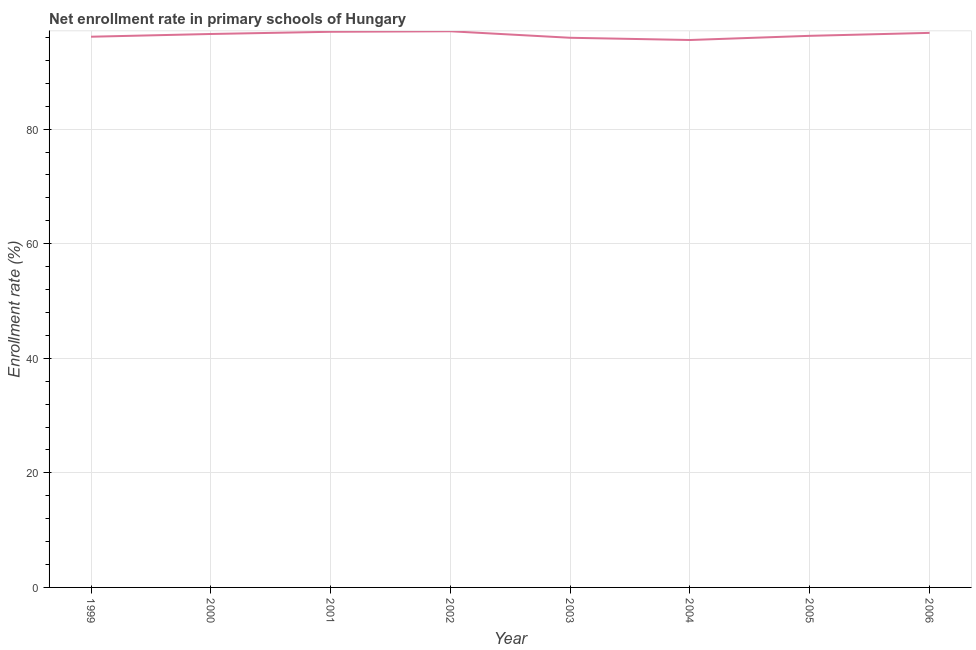What is the net enrollment rate in primary schools in 2004?
Ensure brevity in your answer.  95.55. Across all years, what is the maximum net enrollment rate in primary schools?
Your answer should be compact. 97.08. Across all years, what is the minimum net enrollment rate in primary schools?
Ensure brevity in your answer.  95.55. What is the sum of the net enrollment rate in primary schools?
Ensure brevity in your answer.  771.37. What is the difference between the net enrollment rate in primary schools in 2003 and 2006?
Provide a short and direct response. -0.86. What is the average net enrollment rate in primary schools per year?
Give a very brief answer. 96.42. What is the median net enrollment rate in primary schools?
Your answer should be compact. 96.44. Do a majority of the years between 2001 and 2002 (inclusive) have net enrollment rate in primary schools greater than 80 %?
Provide a succinct answer. Yes. What is the ratio of the net enrollment rate in primary schools in 1999 to that in 2004?
Provide a succinct answer. 1.01. Is the net enrollment rate in primary schools in 1999 less than that in 2005?
Your response must be concise. Yes. Is the difference between the net enrollment rate in primary schools in 2003 and 2005 greater than the difference between any two years?
Provide a short and direct response. No. What is the difference between the highest and the second highest net enrollment rate in primary schools?
Your answer should be very brief. 0.09. Is the sum of the net enrollment rate in primary schools in 2003 and 2004 greater than the maximum net enrollment rate in primary schools across all years?
Keep it short and to the point. Yes. What is the difference between the highest and the lowest net enrollment rate in primary schools?
Your answer should be very brief. 1.53. In how many years, is the net enrollment rate in primary schools greater than the average net enrollment rate in primary schools taken over all years?
Provide a short and direct response. 4. Does the net enrollment rate in primary schools monotonically increase over the years?
Provide a short and direct response. No. How many years are there in the graph?
Offer a very short reply. 8. What is the difference between two consecutive major ticks on the Y-axis?
Keep it short and to the point. 20. What is the title of the graph?
Provide a short and direct response. Net enrollment rate in primary schools of Hungary. What is the label or title of the Y-axis?
Give a very brief answer. Enrollment rate (%). What is the Enrollment rate (%) of 1999?
Ensure brevity in your answer.  96.13. What is the Enrollment rate (%) of 2000?
Keep it short and to the point. 96.6. What is the Enrollment rate (%) of 2001?
Make the answer very short. 96.99. What is the Enrollment rate (%) in 2002?
Your answer should be very brief. 97.08. What is the Enrollment rate (%) of 2003?
Offer a terse response. 95.94. What is the Enrollment rate (%) of 2004?
Your answer should be very brief. 95.55. What is the Enrollment rate (%) in 2005?
Make the answer very short. 96.28. What is the Enrollment rate (%) of 2006?
Give a very brief answer. 96.8. What is the difference between the Enrollment rate (%) in 1999 and 2000?
Give a very brief answer. -0.48. What is the difference between the Enrollment rate (%) in 1999 and 2001?
Offer a very short reply. -0.86. What is the difference between the Enrollment rate (%) in 1999 and 2002?
Offer a terse response. -0.95. What is the difference between the Enrollment rate (%) in 1999 and 2003?
Offer a terse response. 0.18. What is the difference between the Enrollment rate (%) in 1999 and 2004?
Ensure brevity in your answer.  0.57. What is the difference between the Enrollment rate (%) in 1999 and 2005?
Your answer should be compact. -0.16. What is the difference between the Enrollment rate (%) in 1999 and 2006?
Provide a short and direct response. -0.67. What is the difference between the Enrollment rate (%) in 2000 and 2001?
Your answer should be compact. -0.38. What is the difference between the Enrollment rate (%) in 2000 and 2002?
Give a very brief answer. -0.48. What is the difference between the Enrollment rate (%) in 2000 and 2003?
Offer a very short reply. 0.66. What is the difference between the Enrollment rate (%) in 2000 and 2004?
Your response must be concise. 1.05. What is the difference between the Enrollment rate (%) in 2000 and 2005?
Ensure brevity in your answer.  0.32. What is the difference between the Enrollment rate (%) in 2000 and 2006?
Your answer should be very brief. -0.19. What is the difference between the Enrollment rate (%) in 2001 and 2002?
Provide a succinct answer. -0.09. What is the difference between the Enrollment rate (%) in 2001 and 2003?
Your response must be concise. 1.05. What is the difference between the Enrollment rate (%) in 2001 and 2004?
Ensure brevity in your answer.  1.43. What is the difference between the Enrollment rate (%) in 2001 and 2005?
Your answer should be compact. 0.71. What is the difference between the Enrollment rate (%) in 2001 and 2006?
Keep it short and to the point. 0.19. What is the difference between the Enrollment rate (%) in 2002 and 2003?
Keep it short and to the point. 1.14. What is the difference between the Enrollment rate (%) in 2002 and 2004?
Your answer should be compact. 1.53. What is the difference between the Enrollment rate (%) in 2002 and 2005?
Make the answer very short. 0.8. What is the difference between the Enrollment rate (%) in 2002 and 2006?
Ensure brevity in your answer.  0.28. What is the difference between the Enrollment rate (%) in 2003 and 2004?
Offer a terse response. 0.39. What is the difference between the Enrollment rate (%) in 2003 and 2005?
Provide a succinct answer. -0.34. What is the difference between the Enrollment rate (%) in 2003 and 2006?
Your response must be concise. -0.86. What is the difference between the Enrollment rate (%) in 2004 and 2005?
Make the answer very short. -0.73. What is the difference between the Enrollment rate (%) in 2004 and 2006?
Provide a short and direct response. -1.25. What is the difference between the Enrollment rate (%) in 2005 and 2006?
Your response must be concise. -0.52. What is the ratio of the Enrollment rate (%) in 1999 to that in 2000?
Your answer should be very brief. 0.99. What is the ratio of the Enrollment rate (%) in 1999 to that in 2002?
Provide a short and direct response. 0.99. What is the ratio of the Enrollment rate (%) in 1999 to that in 2004?
Keep it short and to the point. 1.01. What is the ratio of the Enrollment rate (%) in 1999 to that in 2006?
Keep it short and to the point. 0.99. What is the ratio of the Enrollment rate (%) in 2000 to that in 2006?
Provide a short and direct response. 1. What is the ratio of the Enrollment rate (%) in 2001 to that in 2003?
Offer a terse response. 1.01. What is the ratio of the Enrollment rate (%) in 2001 to that in 2005?
Offer a terse response. 1.01. What is the ratio of the Enrollment rate (%) in 2001 to that in 2006?
Give a very brief answer. 1. What is the ratio of the Enrollment rate (%) in 2002 to that in 2003?
Your response must be concise. 1.01. What is the ratio of the Enrollment rate (%) in 2002 to that in 2004?
Provide a succinct answer. 1.02. What is the ratio of the Enrollment rate (%) in 2004 to that in 2005?
Your response must be concise. 0.99. 